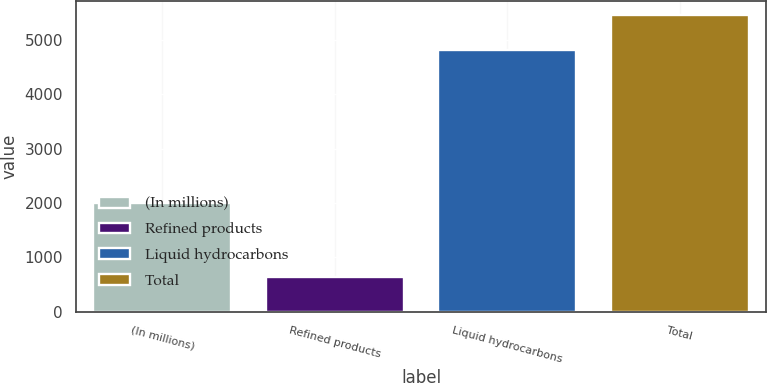<chart> <loc_0><loc_0><loc_500><loc_500><bar_chart><fcel>(In millions)<fcel>Refined products<fcel>Liquid hydrocarbons<fcel>Total<nl><fcel>2006<fcel>645<fcel>4812<fcel>5457<nl></chart> 